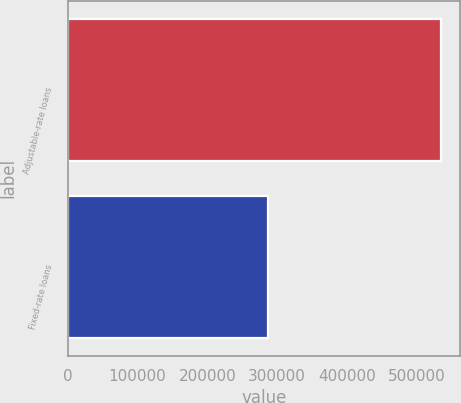Convert chart. <chart><loc_0><loc_0><loc_500><loc_500><bar_chart><fcel>Adjustable-rate loans<fcel>Fixed-rate loans<nl><fcel>534943<fcel>286894<nl></chart> 